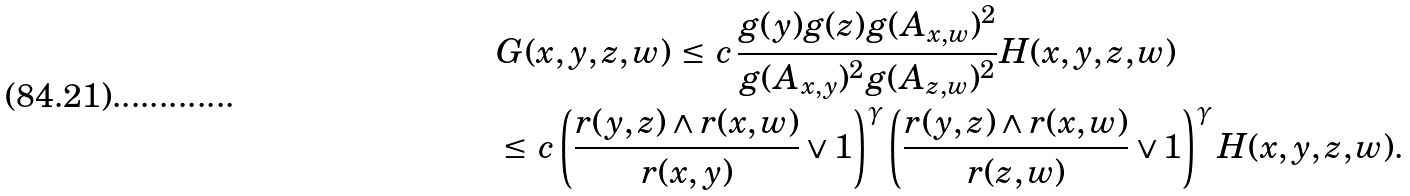Convert formula to latex. <formula><loc_0><loc_0><loc_500><loc_500>& G ( x , y , z , w ) \, \leq \, c \, \frac { g ( y ) g ( z ) g ( A _ { x , w } ) ^ { 2 } } { g ( A _ { x , y } ) ^ { 2 } g ( A _ { z , w } ) ^ { 2 } } H ( x , y , z , w ) \\ & \leq \, c \left ( \frac { r ( y , z ) \wedge r ( x , w ) } { r ( x , y ) } \vee 1 \right ) ^ { \gamma } \left ( \frac { r ( y , z ) \wedge r ( x , w ) } { r ( z , w ) } \vee 1 \right ) ^ { \gamma } H ( x , y , z , w ) .</formula> 